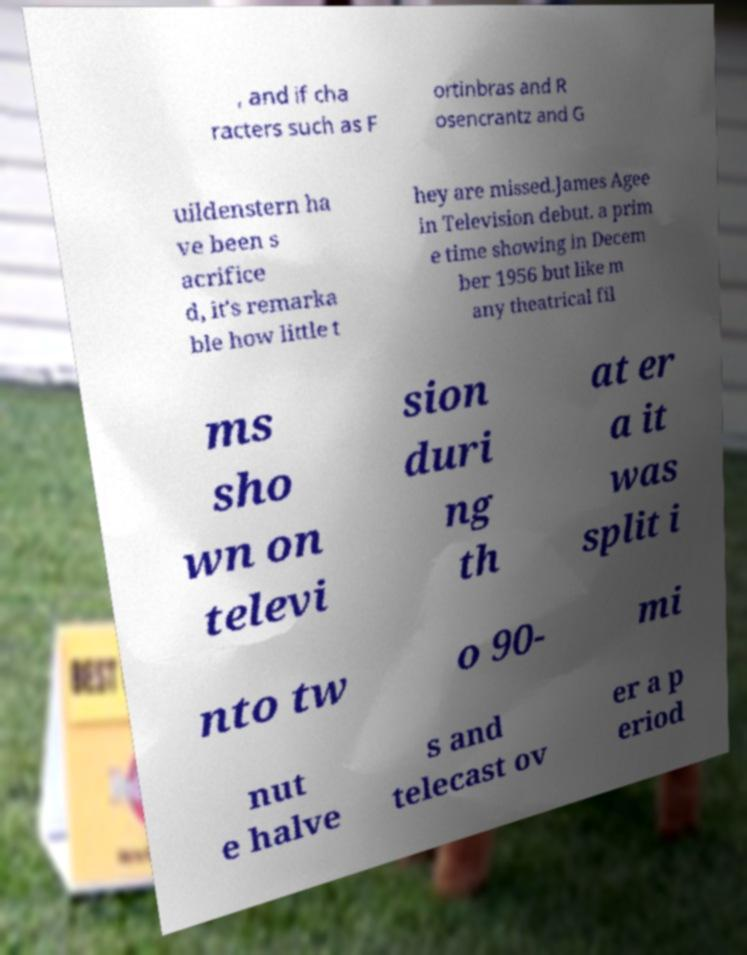Can you read and provide the text displayed in the image?This photo seems to have some interesting text. Can you extract and type it out for me? , and if cha racters such as F ortinbras and R osencrantz and G uildenstern ha ve been s acrifice d, it's remarka ble how little t hey are missed.James Agee in Television debut. a prim e time showing in Decem ber 1956 but like m any theatrical fil ms sho wn on televi sion duri ng th at er a it was split i nto tw o 90- mi nut e halve s and telecast ov er a p eriod 